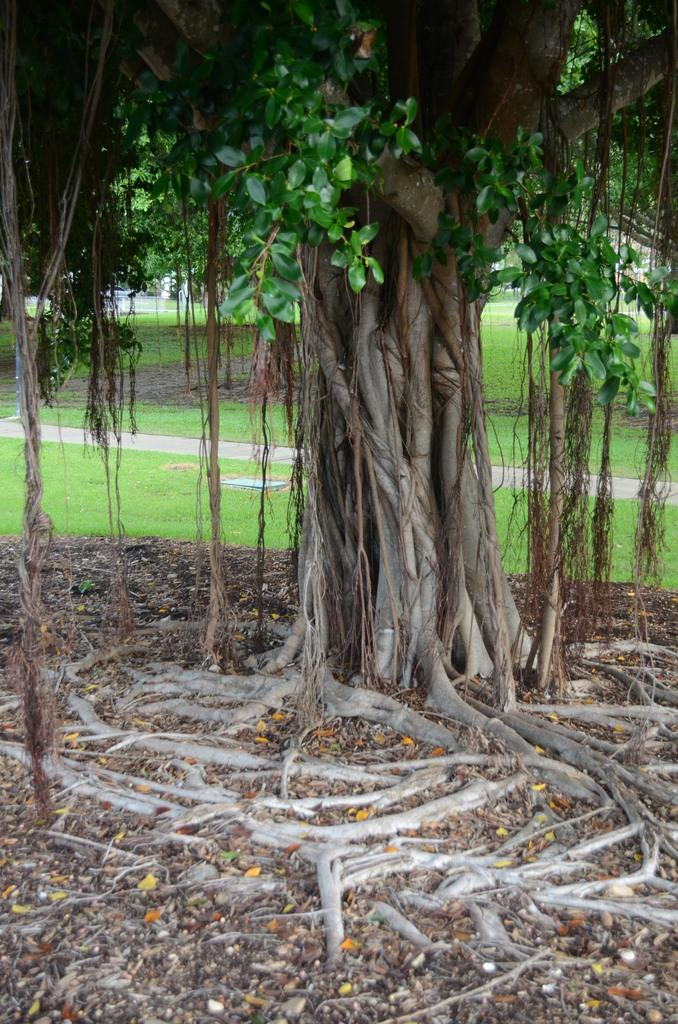What is the main subject in the image? There is a tree in the image. What part of the tree can be seen in the image? The tree's roots are visible in the image. What type of vegetation is visible in the background of the image? There is grass in the background of the image. How many kittens are sitting on the stone near the tree in the image? There are no kittens or stones present in the image. Is there any indication of a wound on the tree in the image? There is no indication of a wound on the tree in the image. 